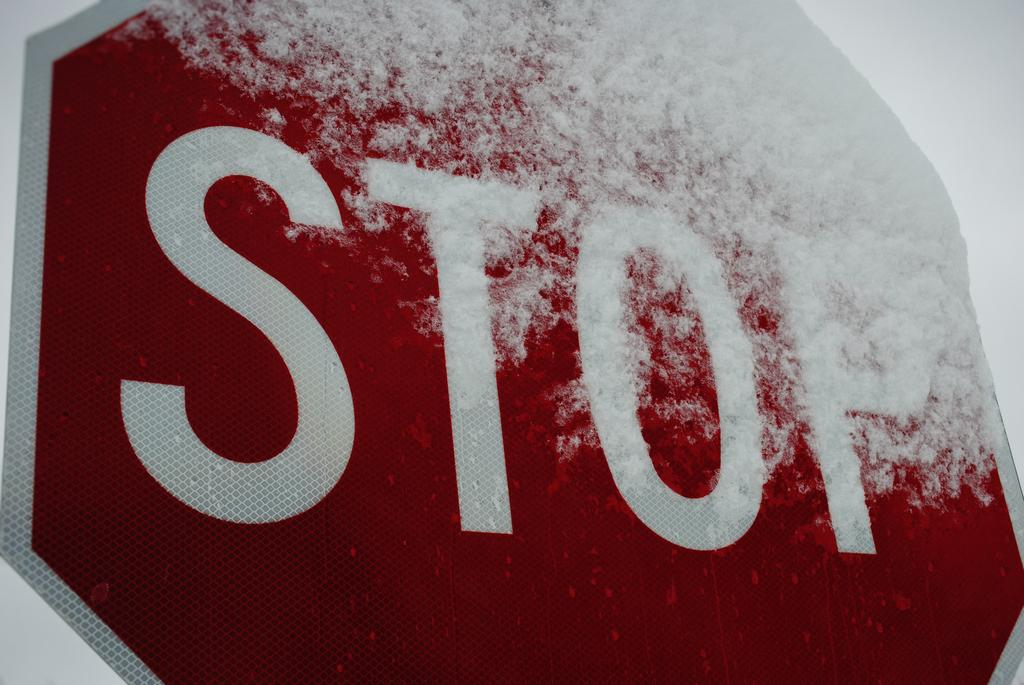<image>
Describe the image concisely. A stop sign that is half covered in snow. 